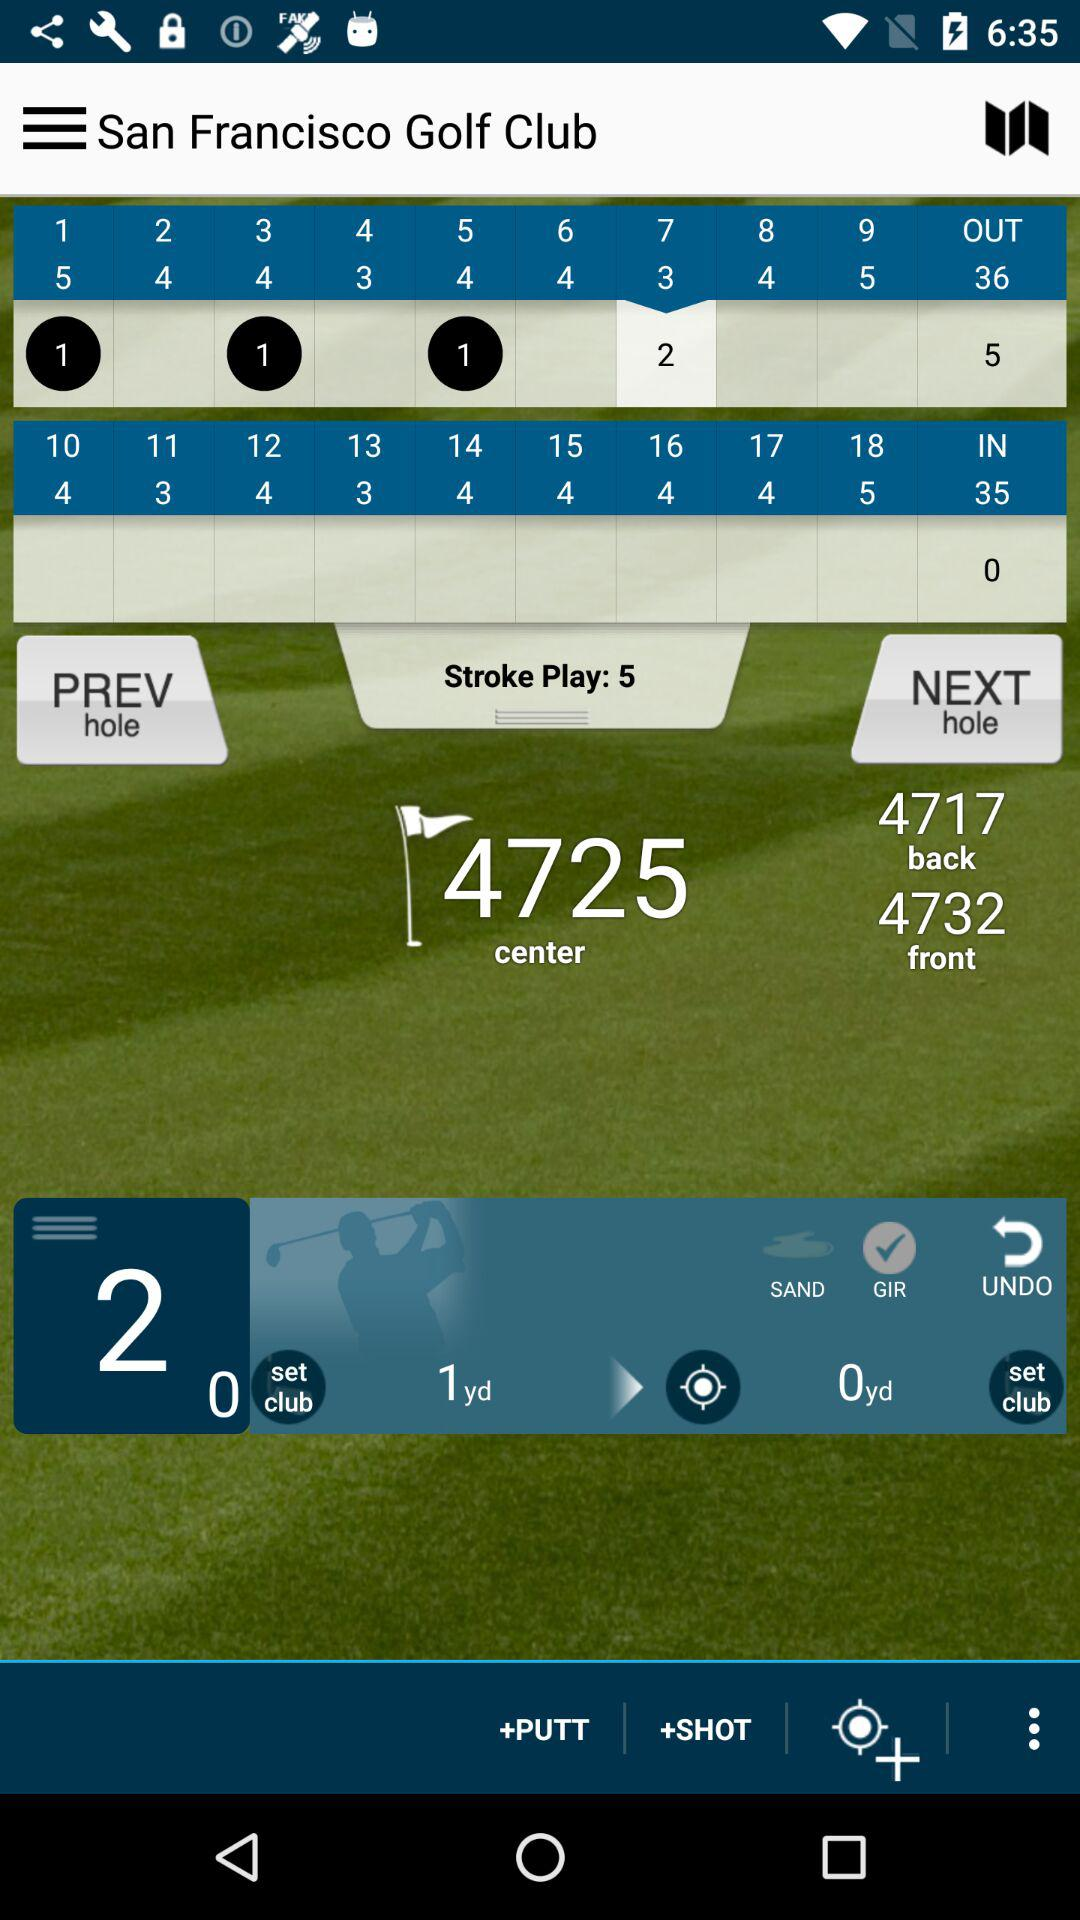What is the center number? The center number is 4725. 